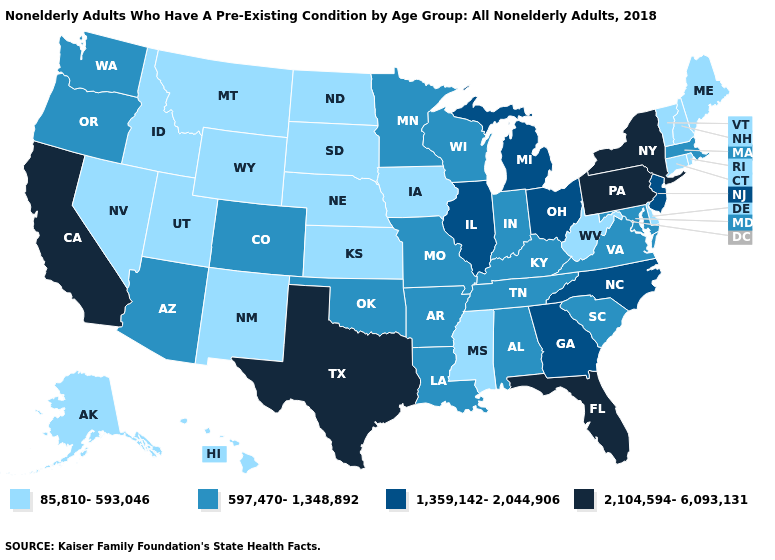Name the states that have a value in the range 597,470-1,348,892?
Answer briefly. Alabama, Arizona, Arkansas, Colorado, Indiana, Kentucky, Louisiana, Maryland, Massachusetts, Minnesota, Missouri, Oklahoma, Oregon, South Carolina, Tennessee, Virginia, Washington, Wisconsin. Does the first symbol in the legend represent the smallest category?
Answer briefly. Yes. Name the states that have a value in the range 85,810-593,046?
Concise answer only. Alaska, Connecticut, Delaware, Hawaii, Idaho, Iowa, Kansas, Maine, Mississippi, Montana, Nebraska, Nevada, New Hampshire, New Mexico, North Dakota, Rhode Island, South Dakota, Utah, Vermont, West Virginia, Wyoming. Does Oklahoma have the highest value in the USA?
Keep it brief. No. What is the value of Indiana?
Concise answer only. 597,470-1,348,892. Does New Mexico have the lowest value in the West?
Be succinct. Yes. Does Alaska have the lowest value in the USA?
Be succinct. Yes. What is the highest value in the USA?
Answer briefly. 2,104,594-6,093,131. Which states hav the highest value in the Northeast?
Give a very brief answer. New York, Pennsylvania. Name the states that have a value in the range 597,470-1,348,892?
Answer briefly. Alabama, Arizona, Arkansas, Colorado, Indiana, Kentucky, Louisiana, Maryland, Massachusetts, Minnesota, Missouri, Oklahoma, Oregon, South Carolina, Tennessee, Virginia, Washington, Wisconsin. Among the states that border South Dakota , does North Dakota have the lowest value?
Short answer required. Yes. What is the value of Ohio?
Keep it brief. 1,359,142-2,044,906. Among the states that border Missouri , which have the highest value?
Concise answer only. Illinois. Does Michigan have the highest value in the USA?
Answer briefly. No. 